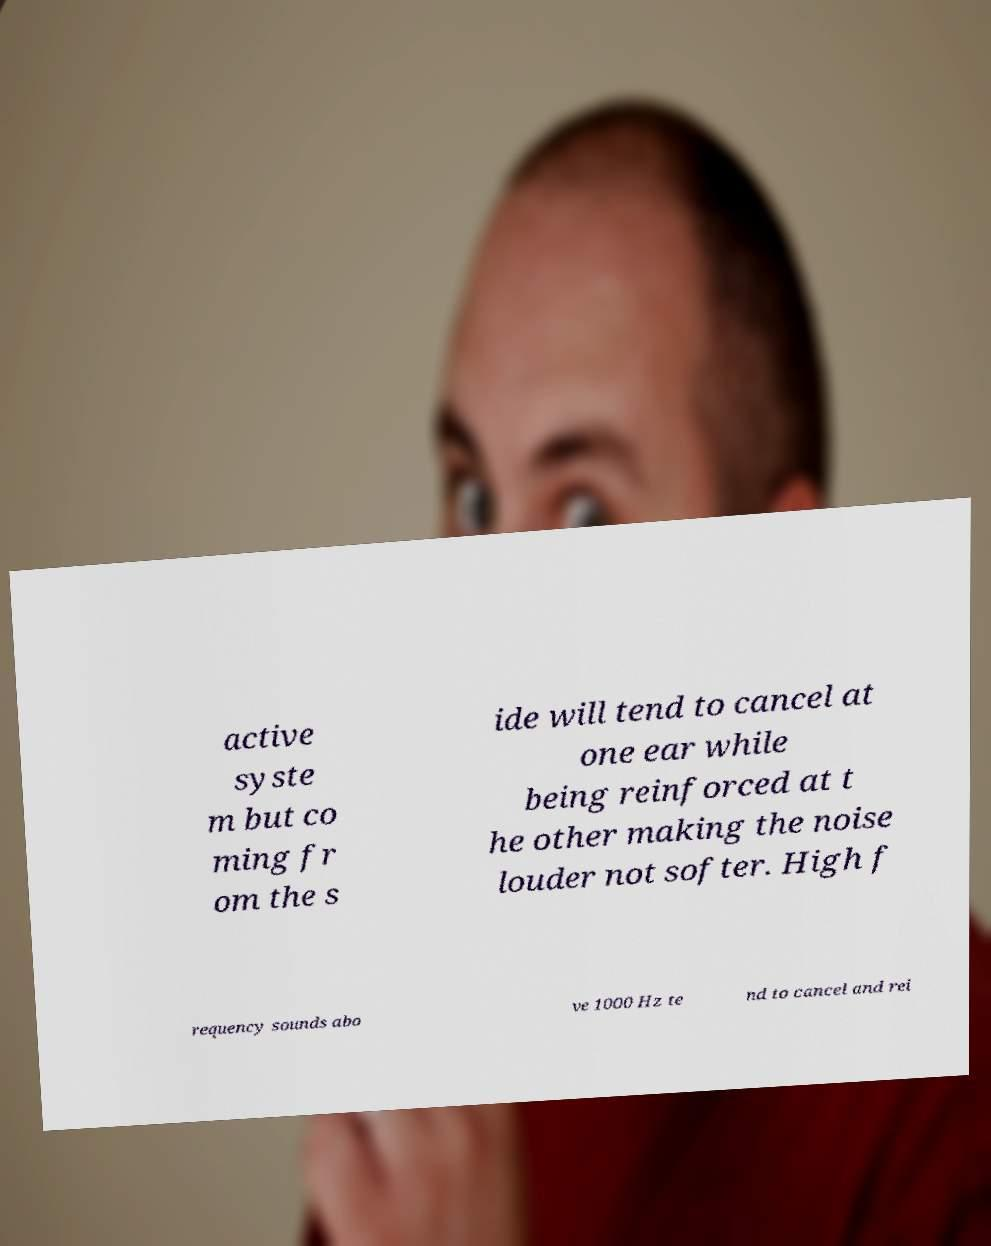I need the written content from this picture converted into text. Can you do that? active syste m but co ming fr om the s ide will tend to cancel at one ear while being reinforced at t he other making the noise louder not softer. High f requency sounds abo ve 1000 Hz te nd to cancel and rei 